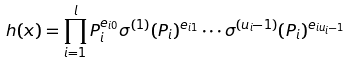<formula> <loc_0><loc_0><loc_500><loc_500>h ( x ) = \prod _ { i = 1 } ^ { l } P _ { i } ^ { e _ { i 0 } } \sigma ^ { ( 1 ) } ( P _ { i } ) ^ { e _ { i 1 } } \cdots \sigma ^ { ( { u _ { i } - 1 } ) } ( P _ { i } ) ^ { e _ { i u _ { i } - 1 } }</formula> 